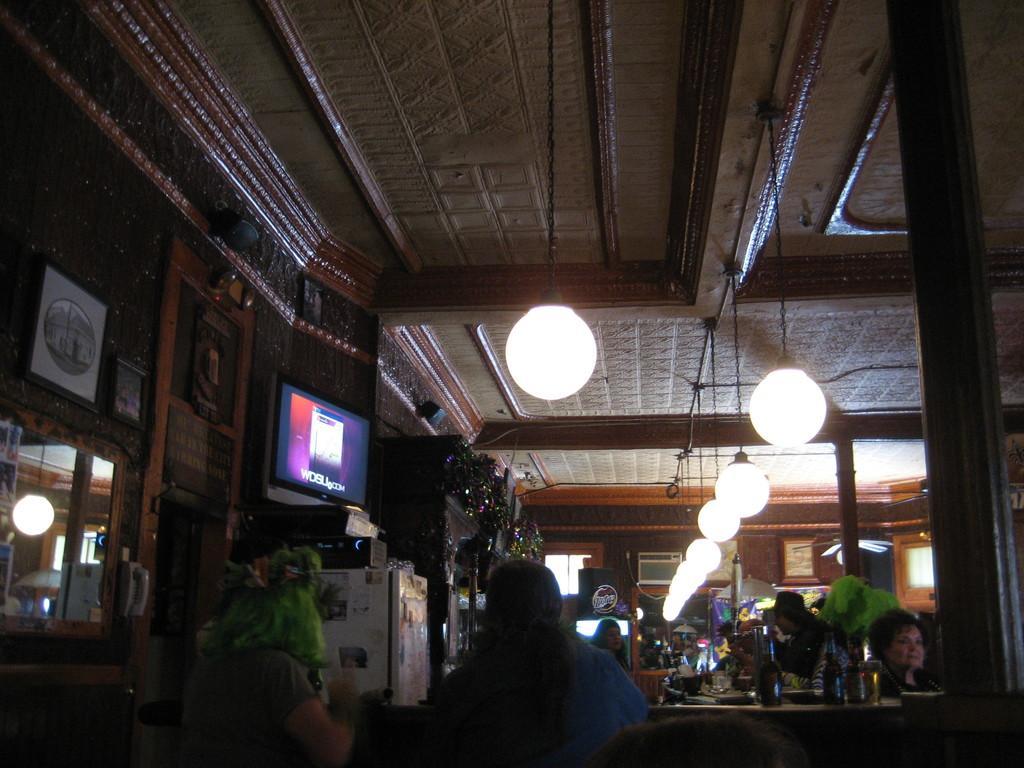Describe this image in one or two sentences. In this picture I can observe some people sitting on the chairs in front of their tables. I can observe some lights hanging to the ceilings. On the left side I can observe a television. 